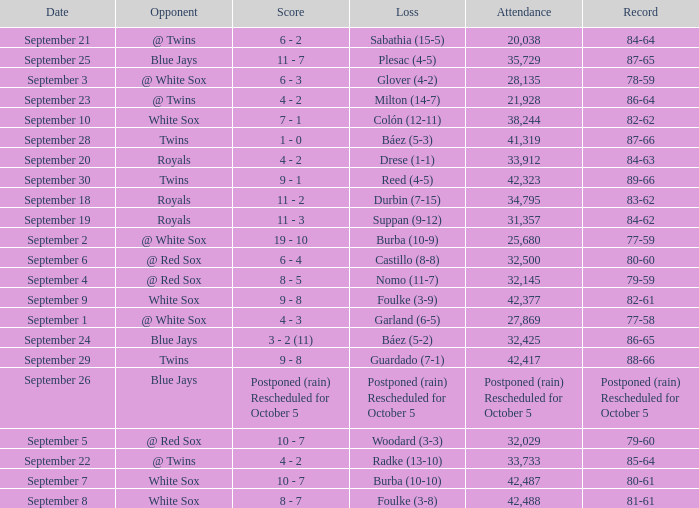What is the record of the game with 28,135 people in attendance? 78-59. 